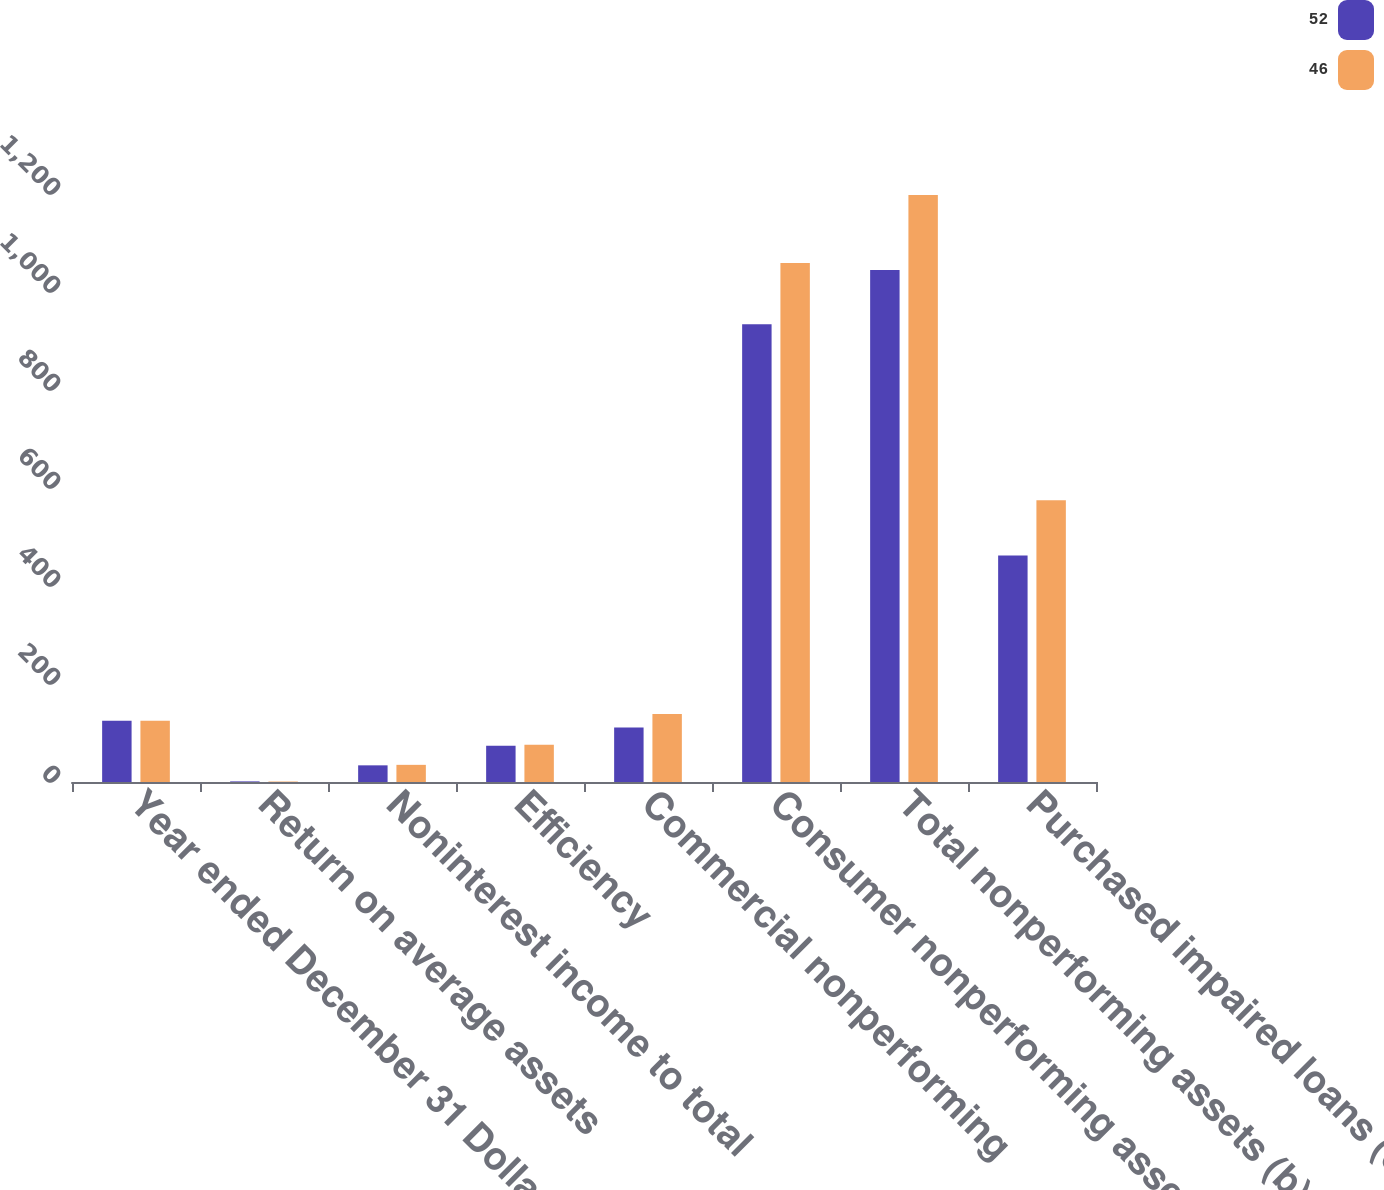Convert chart to OTSL. <chart><loc_0><loc_0><loc_500><loc_500><stacked_bar_chart><ecel><fcel>Year ended December 31 Dollars<fcel>Return on average assets<fcel>Noninterest income to total<fcel>Efficiency<fcel>Commercial nonperforming<fcel>Consumer nonperforming assets<fcel>Total nonperforming assets (b)<fcel>Purchased impaired loans (c)<nl><fcel>52<fcel>125<fcel>1.24<fcel>34<fcel>74<fcel>111<fcel>934<fcel>1045<fcel>462<nl><fcel>46<fcel>125<fcel>0.97<fcel>35<fcel>76<fcel>139<fcel>1059<fcel>1198<fcel>575<nl></chart> 